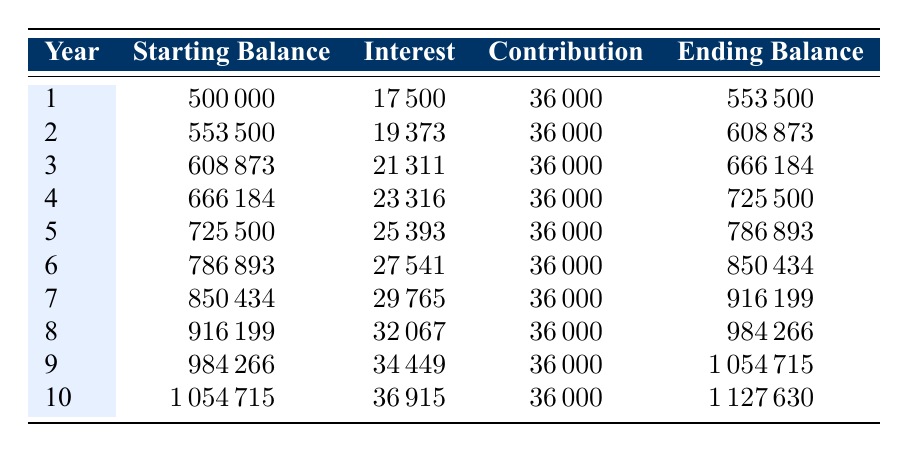What is the ending balance after the first year? The ending balance at the end of the first year is found in the table under the "Ending Balance" column for Year 1, which shows 553500.
Answer: 553500 How much interest is earned in Year 5? The interest earned in Year 5 can be found in the "Interest" column for Year 5, which is 25393.
Answer: 25393 What is the total contribution made over the 10 years? The total contribution can be calculated by multiplying the monthly contribution by the number of months over 10 years. The formula is 3000 multiplied by 12 months per year multiplied by 10 years, which equals 360000.
Answer: 360000 Is the interest earned decreasing each year? To determine if the interest earned is decreasing, we can compare the interest values from Year 1 to Year 10 in the table. The interest amounts are: 17500, 19373, 21311, 23316, 25393, 27541, 29765, 32067, 34449, and 36915, which shows that the interest is increasing each year.
Answer: No What is the average ending balance over the 10 years? To find the average ending balance, we add the ending balances for all 10 years (553500 + 608873 + 666184 + 725500 + 786893 + 850434 + 916199 + 984266 + 1054715 + 1127630) which sums to 1010806. Then, we divide this total by 10 (the number of years), resulting in an average of 101080.6.
Answer: 101080.6 In which year does the ending balance first exceed one million? Looking through the table, we examine the "Ending Balance" rows and find that the first time the ending balance exceeds one million is in Year 9, where the ending balance is 1054715.
Answer: Year 9 How much total interest is earned over the ten years? The total interest for the decade can be computed by adding up the yearly interest figures: (17500 + 19373 + 21311 + 23316 + 25393 + 27541 + 29765 + 32067 + 34449 + 36915), which equals 205800.
Answer: 205800 Is the total funding from community fundraisers higher than from parish donations? Comparing the amounts in the "Funding Sources" section, community fundraisers amount to 200000 and parish donations to 150000. Since 200000 is higher than 150000, the answer is yes.
Answer: Yes 